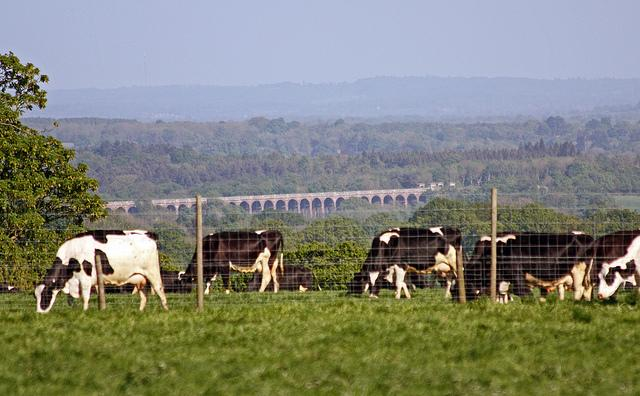The cow belongs to which genus? bos 